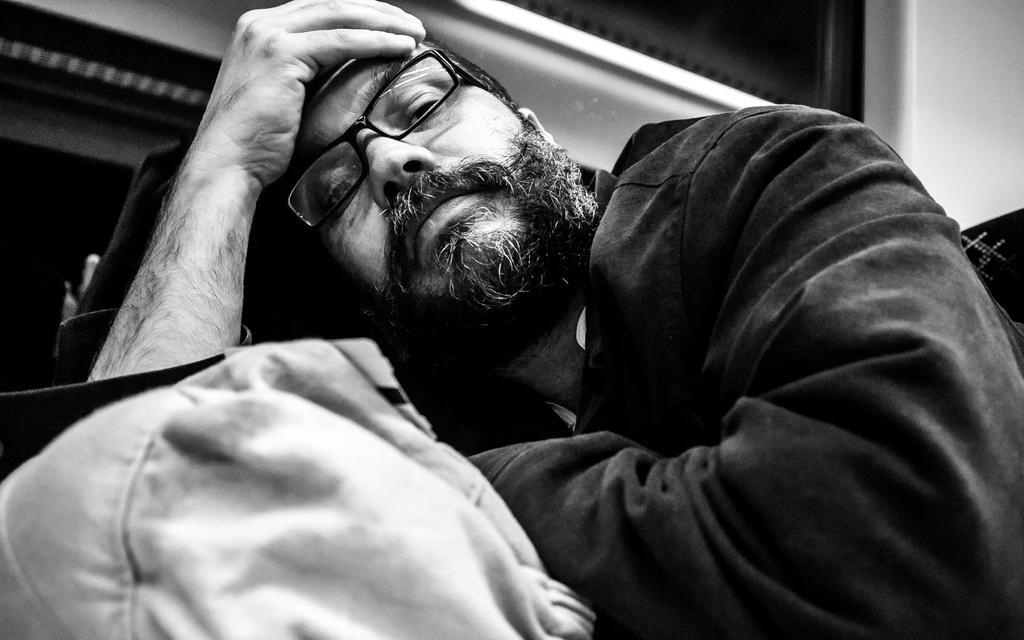How would you summarize this image in a sentence or two? In this picture we can see a man wore spectacle, bag and in the background we can see wall. 